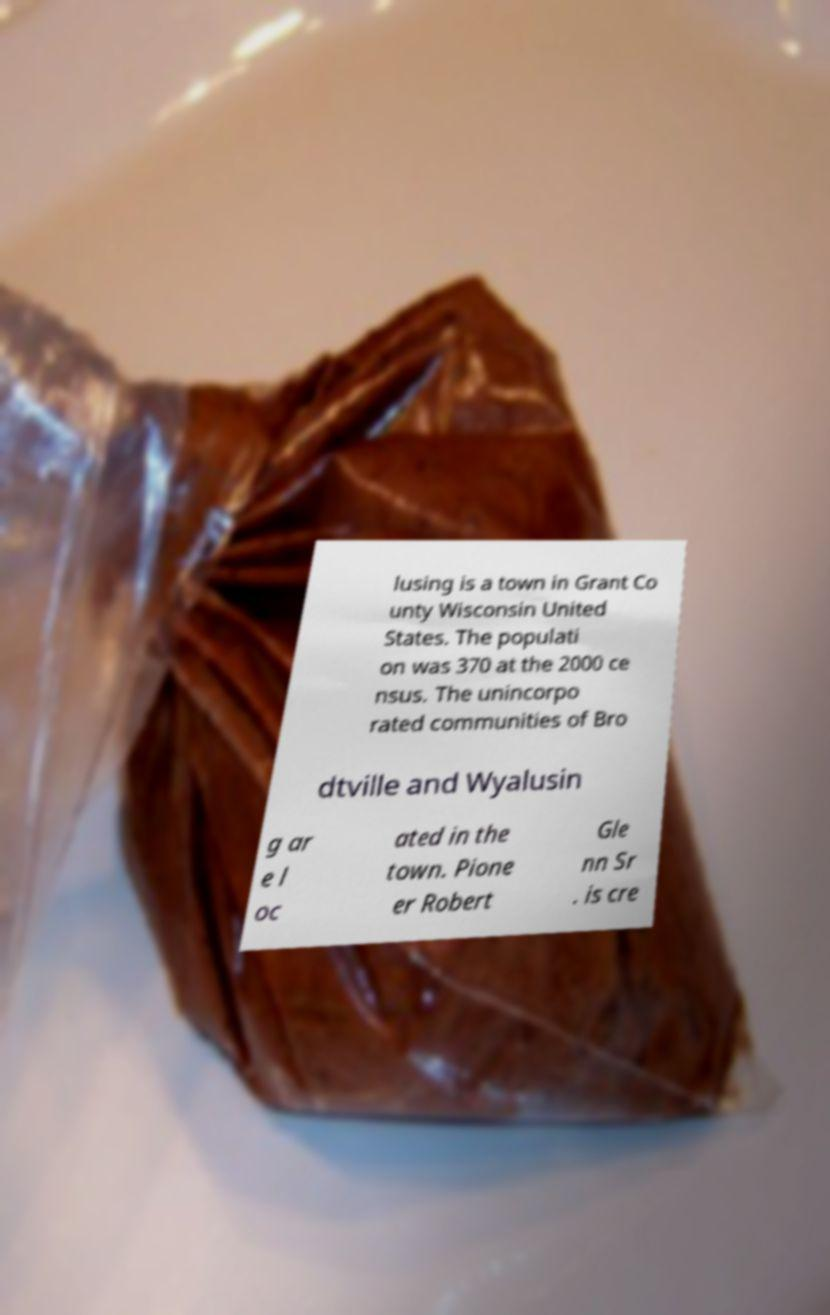Can you read and provide the text displayed in the image?This photo seems to have some interesting text. Can you extract and type it out for me? lusing is a town in Grant Co unty Wisconsin United States. The populati on was 370 at the 2000 ce nsus. The unincorpo rated communities of Bro dtville and Wyalusin g ar e l oc ated in the town. Pione er Robert Gle nn Sr . is cre 